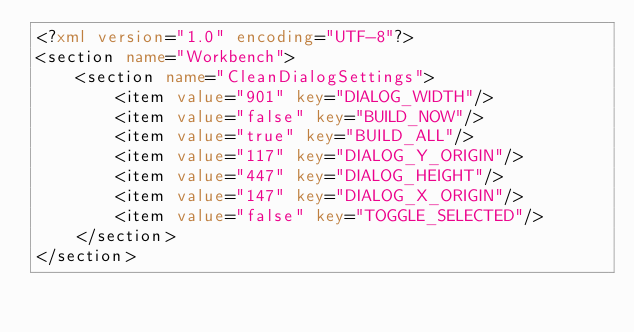Convert code to text. <code><loc_0><loc_0><loc_500><loc_500><_XML_><?xml version="1.0" encoding="UTF-8"?>
<section name="Workbench">
	<section name="CleanDialogSettings">
		<item value="901" key="DIALOG_WIDTH"/>
		<item value="false" key="BUILD_NOW"/>
		<item value="true" key="BUILD_ALL"/>
		<item value="117" key="DIALOG_Y_ORIGIN"/>
		<item value="447" key="DIALOG_HEIGHT"/>
		<item value="147" key="DIALOG_X_ORIGIN"/>
		<item value="false" key="TOGGLE_SELECTED"/>
	</section>
</section>
</code> 